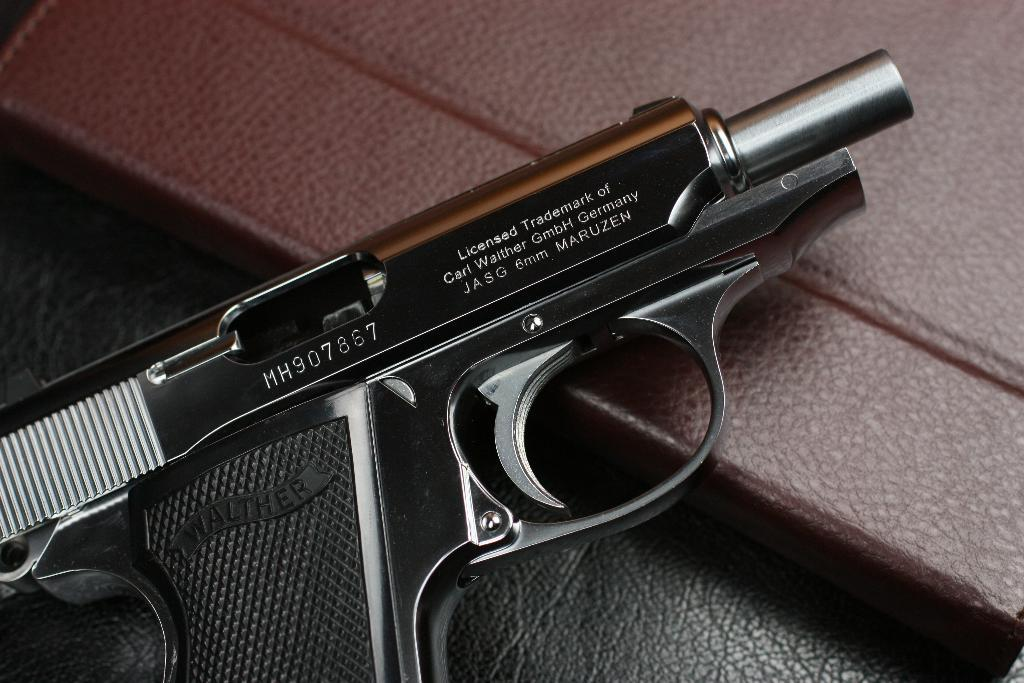What object is the main focus of the image? There is a pistol in the image. What type of attraction is located on the side of the truck in the image? There is no truck or attraction present in the image; it only features a pistol. 